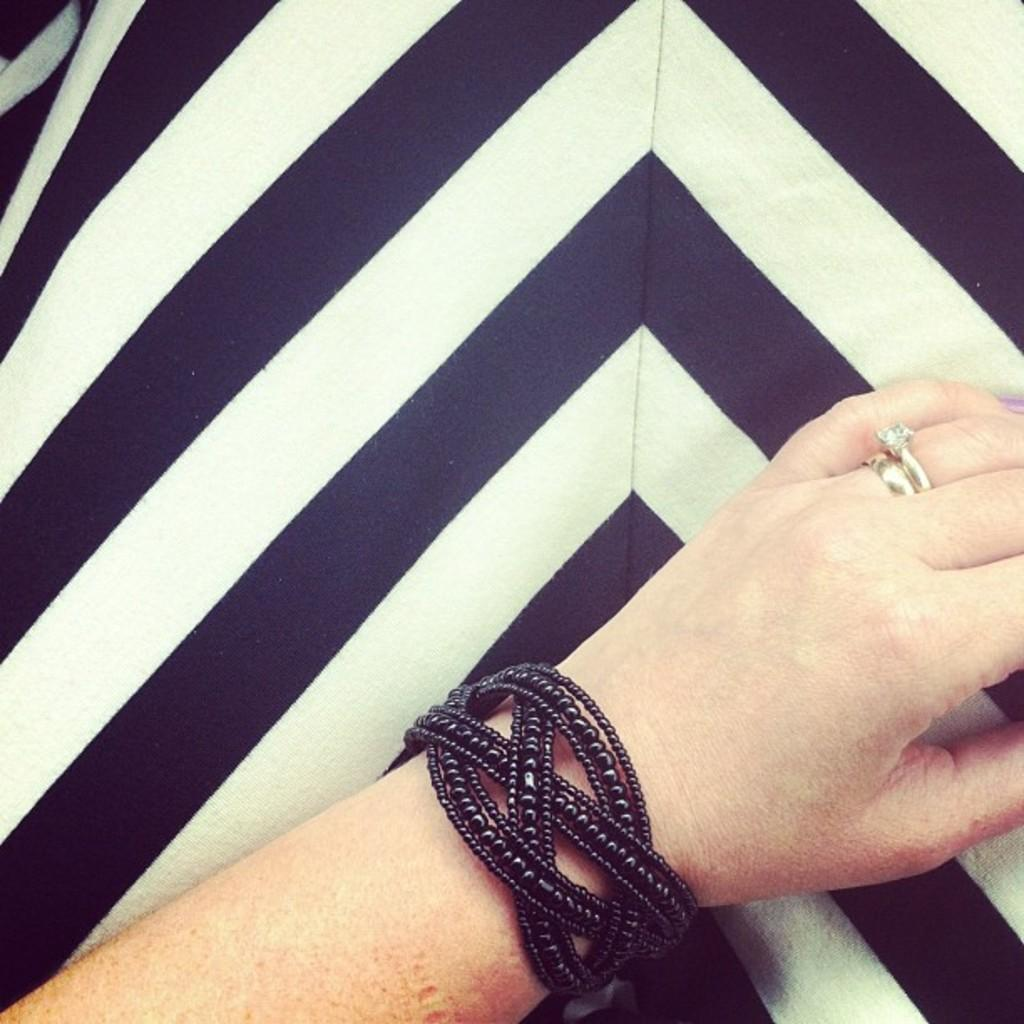What is the main subject of the image? The main subject of the image is a human hand. What can be seen on the hand? The hand has a black bracelet and rings. What is visible in the background of the image? There is a wall in the background of the image. What is the color scheme of the wall? The wall is in black and white color. What type of whip is being used by the person in the image? There is no person or whip present in the image; it only features a human hand with a black bracelet and rings. Is the person wearing a hat in the image? There is no person or hat present in the image; it only features a human hand with a black bracelet and rings. 